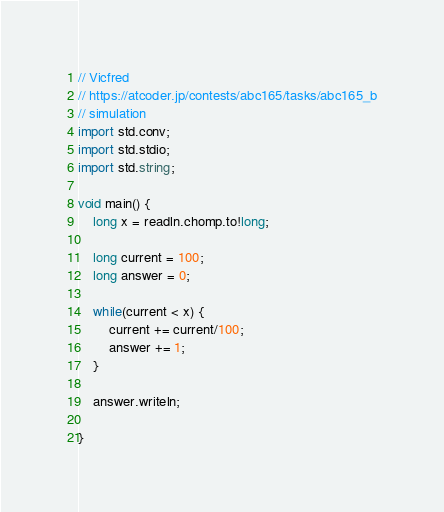<code> <loc_0><loc_0><loc_500><loc_500><_D_>// Vicfred
// https://atcoder.jp/contests/abc165/tasks/abc165_b
// simulation
import std.conv;
import std.stdio;
import std.string;

void main() {
    long x = readln.chomp.to!long;

    long current = 100;
    long answer = 0;

    while(current < x) {
        current += current/100;
        answer += 1;
    }

    answer.writeln;

}

</code> 